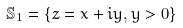<formula> <loc_0><loc_0><loc_500><loc_500>\mathbb { S } _ { 1 } = \{ z = x + i y , y > 0 \}</formula> 